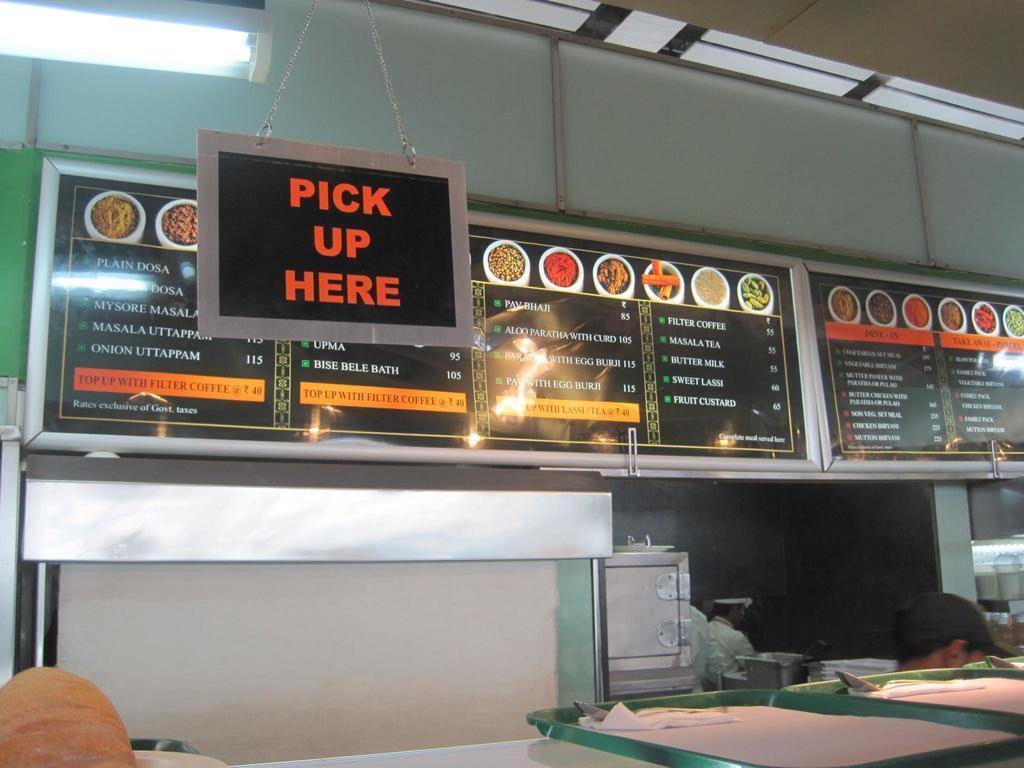Could you give a brief overview of what you see in this image? This is table. On the table there are trays, tissue papers, and spoons. There are persons. In the we can see bowls, boards, and light. 